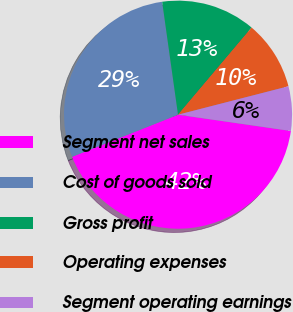Convert chart. <chart><loc_0><loc_0><loc_500><loc_500><pie_chart><fcel>Segment net sales<fcel>Cost of goods sold<fcel>Gross profit<fcel>Operating expenses<fcel>Segment operating earnings<nl><fcel>41.7%<fcel>28.8%<fcel>13.38%<fcel>9.83%<fcel>6.29%<nl></chart> 